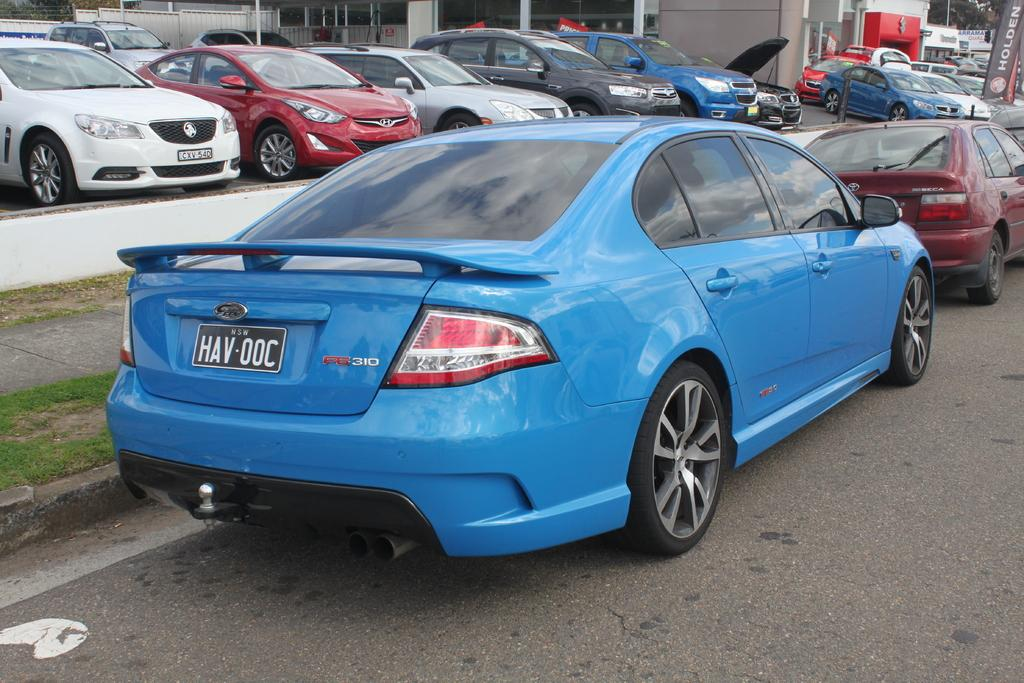What can be seen parked on the road in the image? There are cars parked on the road in the image. What type of vegetation is visible in the image? There is grass visible in the image. What type of barrier can be seen in the image? There is a fence in the image. What vertical structure is present in the image? There is a pole in the image. What flat, rectangular object can be seen in the image? There is a board in the image. What type of tall plants are visible in the image? There are trees in the image. What type of jelly can be seen on the board in the image? There is no jelly present on the board or in the image. Can you describe the cracker that the cars are attempting to eat in the image? There are no crackers or attempts to eat them in the image; it features parked cars and other objects. 